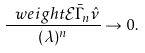<formula> <loc_0><loc_0><loc_500><loc_500>\frac { \ w e i g h t { \mathcal { E } } { \bar { \Gamma } _ { n } } { \hat { \nu } } } { ( \lambda ) ^ { n } } \to 0 .</formula> 